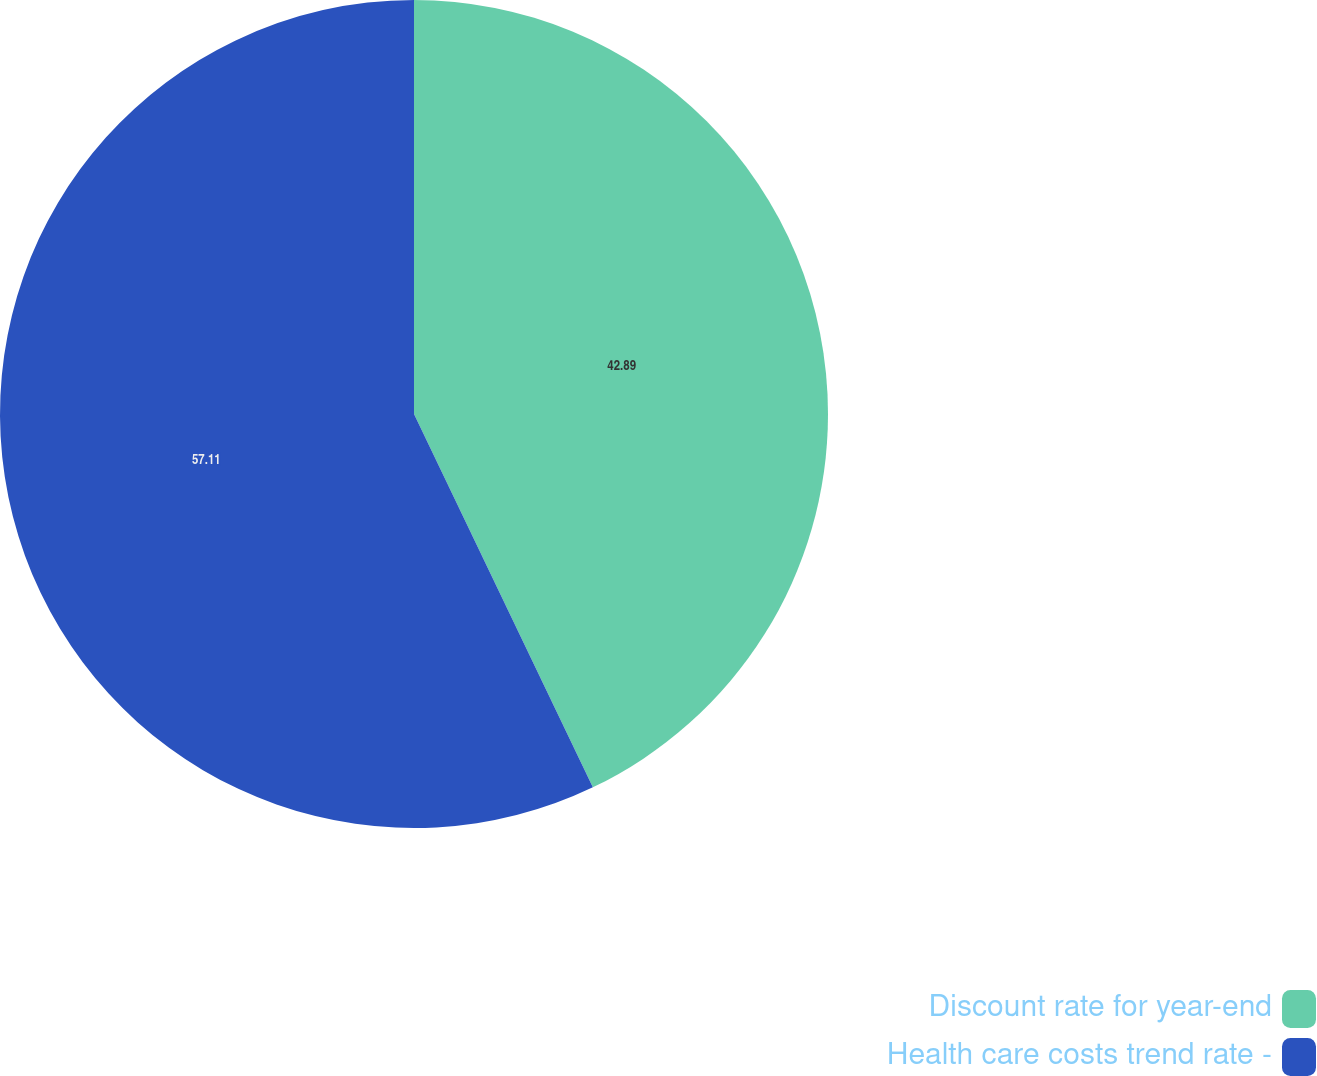<chart> <loc_0><loc_0><loc_500><loc_500><pie_chart><fcel>Discount rate for year-end<fcel>Health care costs trend rate -<nl><fcel>42.89%<fcel>57.11%<nl></chart> 